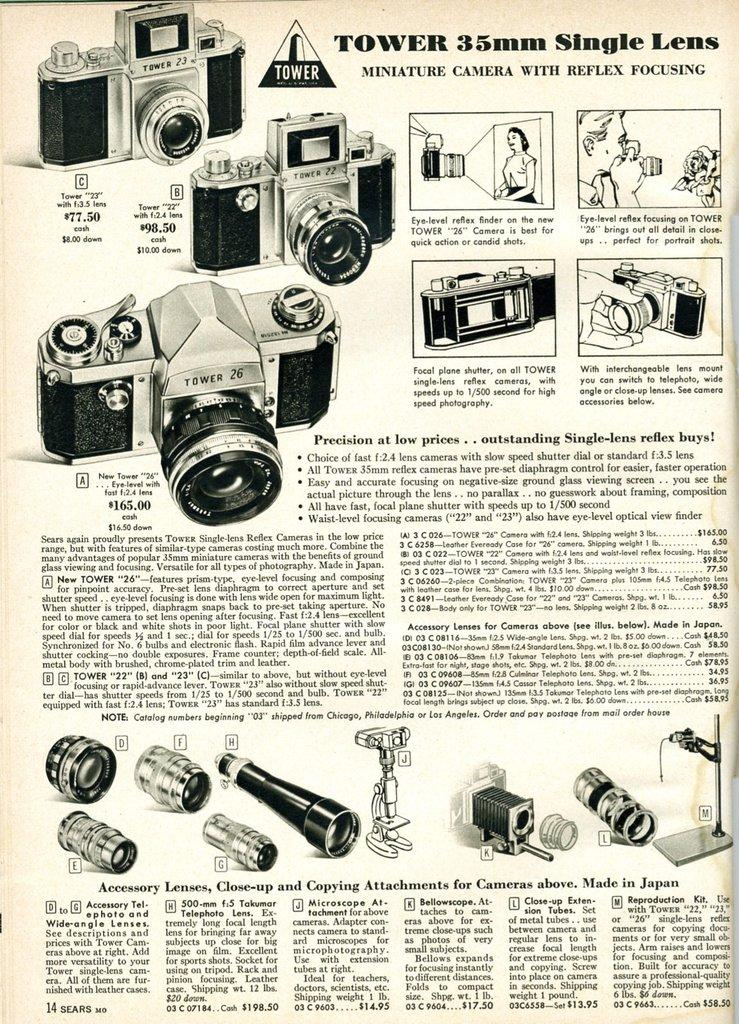What type of publication is depicted in the image? The image is a newspaper. What subject matter is featured in the newspaper? The newspaper contains images of cameras and lenses. What is the color of the text in the newspaper? The text in the newspaper is black. What is the color of the background in the newspaper? The background of the image is white in color. How many owls can be seen in the newspaper? There are no owls present in the newspaper; it features images of cameras and lenses. What type of activity is taking place in the field shown in the newspaper? There is no field or any activity depicted in the newspaper; it is a collection of images and text about cameras and lenses. 